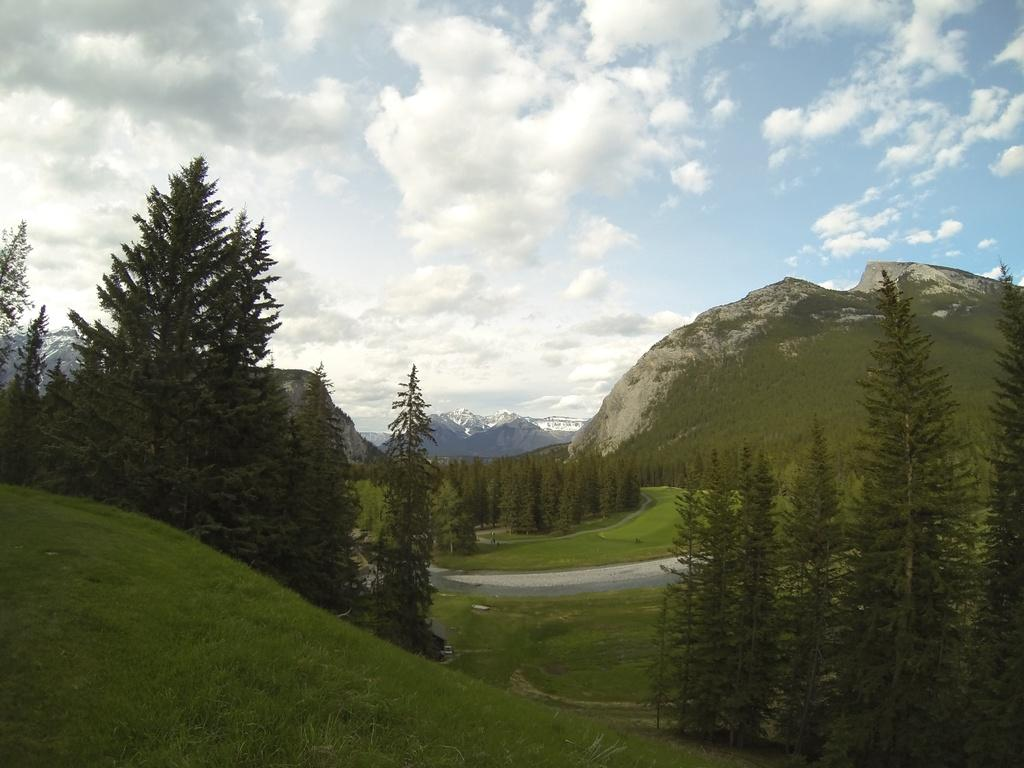What type of vegetation can be seen in the image? There are trees and grass in the image. What geographical features are present in the image? There are hills in the image. What is visible in the background of the image? The sky is visible in the background of the image. What can be seen in the sky in the image? Clouds are present in the sky. Is there a gate visible in the image? There is no gate present in the image. What type of writing can be seen on the trees in the image? There is no writing visible on the trees in the image. 